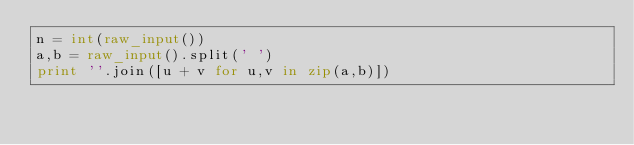<code> <loc_0><loc_0><loc_500><loc_500><_Python_>n = int(raw_input())
a,b = raw_input().split(' ')
print ''.join([u + v for u,v in zip(a,b)])
</code> 